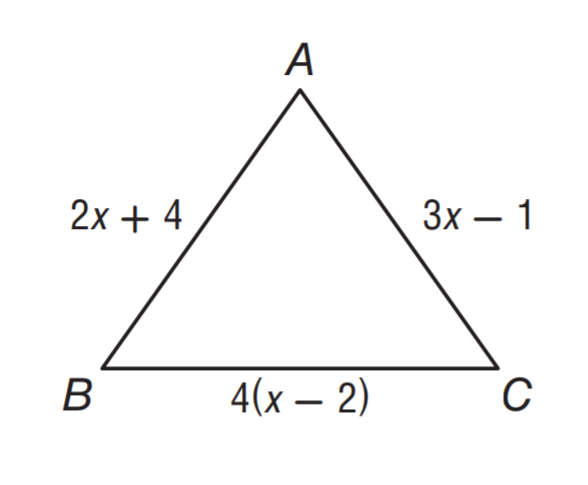Answer the mathemtical geometry problem and directly provide the correct option letter.
Question: \triangle A B C is an isosceles triangle with base B C. What is the perimeter of the triangle?
Choices: A: 5 B: 12 C: 14 D: 40 D 